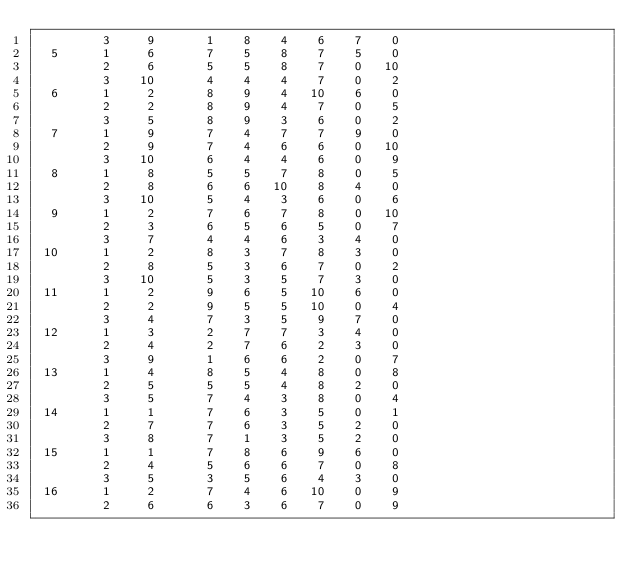<code> <loc_0><loc_0><loc_500><loc_500><_ObjectiveC_>         3     9       1    8    4    6    7    0
  5      1     6       7    5    8    7    5    0
         2     6       5    5    8    7    0   10
         3    10       4    4    4    7    0    2
  6      1     2       8    9    4   10    6    0
         2     2       8    9    4    7    0    5
         3     5       8    9    3    6    0    2
  7      1     9       7    4    7    7    9    0
         2     9       7    4    6    6    0   10
         3    10       6    4    4    6    0    9
  8      1     8       5    5    7    8    0    5
         2     8       6    6   10    8    4    0
         3    10       5    4    3    6    0    6
  9      1     2       7    6    7    8    0   10
         2     3       6    5    6    5    0    7
         3     7       4    4    6    3    4    0
 10      1     2       8    3    7    8    3    0
         2     8       5    3    6    7    0    2
         3    10       5    3    5    7    3    0
 11      1     2       9    6    5   10    6    0
         2     2       9    5    5   10    0    4
         3     4       7    3    5    9    7    0
 12      1     3       2    7    7    3    4    0
         2     4       2    7    6    2    3    0
         3     9       1    6    6    2    0    7
 13      1     4       8    5    4    8    0    8
         2     5       5    5    4    8    2    0
         3     5       7    4    3    8    0    4
 14      1     1       7    6    3    5    0    1
         2     7       7    6    3    5    2    0
         3     8       7    1    3    5    2    0
 15      1     1       7    8    6    9    6    0
         2     4       5    6    6    7    0    8
         3     5       3    5    6    4    3    0
 16      1     2       7    4    6   10    0    9
         2     6       6    3    6    7    0    9</code> 